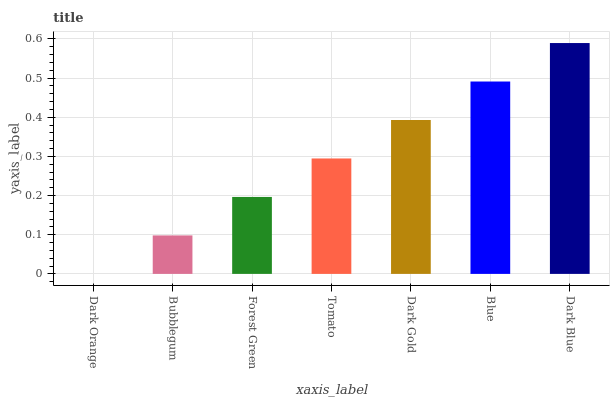Is Dark Orange the minimum?
Answer yes or no. Yes. Is Dark Blue the maximum?
Answer yes or no. Yes. Is Bubblegum the minimum?
Answer yes or no. No. Is Bubblegum the maximum?
Answer yes or no. No. Is Bubblegum greater than Dark Orange?
Answer yes or no. Yes. Is Dark Orange less than Bubblegum?
Answer yes or no. Yes. Is Dark Orange greater than Bubblegum?
Answer yes or no. No. Is Bubblegum less than Dark Orange?
Answer yes or no. No. Is Tomato the high median?
Answer yes or no. Yes. Is Tomato the low median?
Answer yes or no. Yes. Is Bubblegum the high median?
Answer yes or no. No. Is Dark Blue the low median?
Answer yes or no. No. 